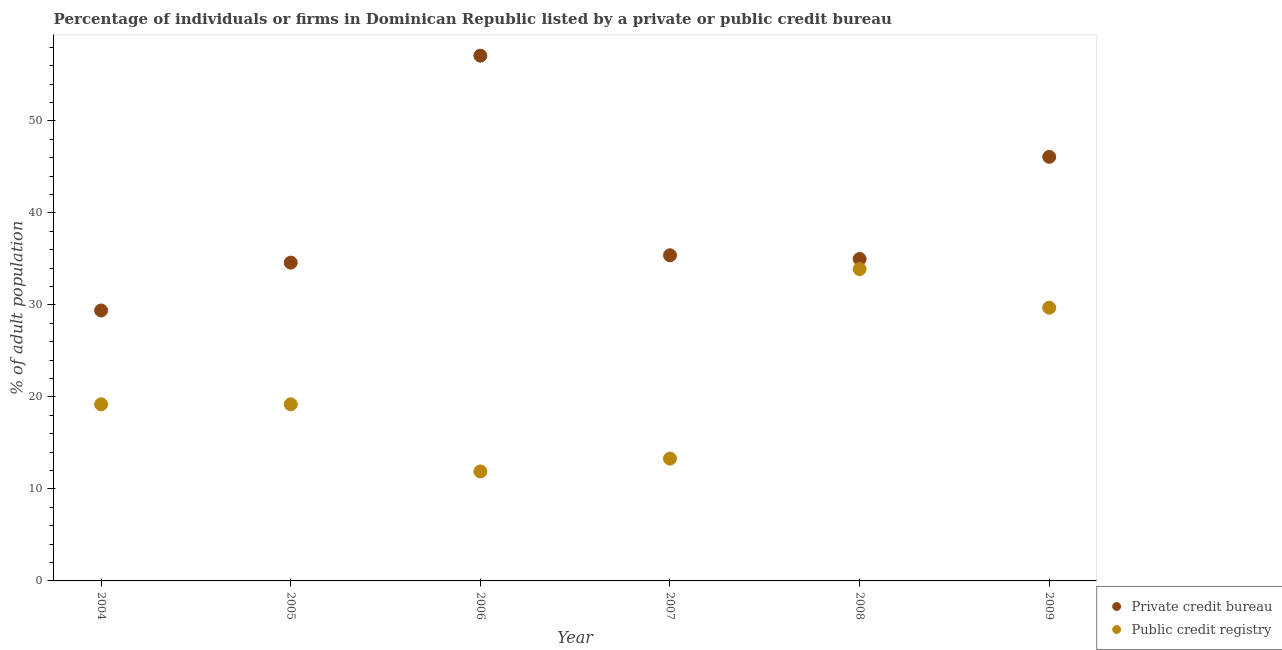Is the number of dotlines equal to the number of legend labels?
Provide a short and direct response. Yes. What is the percentage of firms listed by public credit bureau in 2008?
Make the answer very short. 33.9. Across all years, what is the maximum percentage of firms listed by public credit bureau?
Your answer should be compact. 33.9. Across all years, what is the minimum percentage of firms listed by private credit bureau?
Give a very brief answer. 29.4. In which year was the percentage of firms listed by public credit bureau minimum?
Your answer should be compact. 2006. What is the total percentage of firms listed by private credit bureau in the graph?
Your answer should be compact. 237.6. What is the difference between the percentage of firms listed by public credit bureau in 2007 and that in 2008?
Provide a short and direct response. -20.6. What is the difference between the percentage of firms listed by public credit bureau in 2008 and the percentage of firms listed by private credit bureau in 2009?
Make the answer very short. -12.2. What is the average percentage of firms listed by private credit bureau per year?
Keep it short and to the point. 39.6. In the year 2009, what is the difference between the percentage of firms listed by private credit bureau and percentage of firms listed by public credit bureau?
Your answer should be compact. 16.4. What is the ratio of the percentage of firms listed by public credit bureau in 2004 to that in 2005?
Provide a succinct answer. 1. Is the percentage of firms listed by private credit bureau in 2005 less than that in 2006?
Your response must be concise. Yes. What is the difference between the highest and the second highest percentage of firms listed by public credit bureau?
Your response must be concise. 4.2. Is the percentage of firms listed by public credit bureau strictly greater than the percentage of firms listed by private credit bureau over the years?
Make the answer very short. No. How many years are there in the graph?
Your answer should be compact. 6. Are the values on the major ticks of Y-axis written in scientific E-notation?
Your answer should be compact. No. Does the graph contain grids?
Your answer should be very brief. No. Where does the legend appear in the graph?
Offer a very short reply. Bottom right. How are the legend labels stacked?
Keep it short and to the point. Vertical. What is the title of the graph?
Offer a terse response. Percentage of individuals or firms in Dominican Republic listed by a private or public credit bureau. Does "current US$" appear as one of the legend labels in the graph?
Keep it short and to the point. No. What is the label or title of the X-axis?
Ensure brevity in your answer.  Year. What is the label or title of the Y-axis?
Keep it short and to the point. % of adult population. What is the % of adult population in Private credit bureau in 2004?
Make the answer very short. 29.4. What is the % of adult population of Public credit registry in 2004?
Provide a succinct answer. 19.2. What is the % of adult population of Private credit bureau in 2005?
Provide a succinct answer. 34.6. What is the % of adult population of Public credit registry in 2005?
Keep it short and to the point. 19.2. What is the % of adult population of Private credit bureau in 2006?
Give a very brief answer. 57.1. What is the % of adult population of Public credit registry in 2006?
Give a very brief answer. 11.9. What is the % of adult population in Private credit bureau in 2007?
Offer a very short reply. 35.4. What is the % of adult population of Private credit bureau in 2008?
Your response must be concise. 35. What is the % of adult population of Public credit registry in 2008?
Provide a succinct answer. 33.9. What is the % of adult population in Private credit bureau in 2009?
Your answer should be very brief. 46.1. What is the % of adult population of Public credit registry in 2009?
Provide a succinct answer. 29.7. Across all years, what is the maximum % of adult population in Private credit bureau?
Offer a very short reply. 57.1. Across all years, what is the maximum % of adult population in Public credit registry?
Offer a very short reply. 33.9. Across all years, what is the minimum % of adult population in Private credit bureau?
Provide a succinct answer. 29.4. What is the total % of adult population of Private credit bureau in the graph?
Your answer should be very brief. 237.6. What is the total % of adult population in Public credit registry in the graph?
Ensure brevity in your answer.  127.2. What is the difference between the % of adult population in Private credit bureau in 2004 and that in 2005?
Give a very brief answer. -5.2. What is the difference between the % of adult population of Private credit bureau in 2004 and that in 2006?
Provide a succinct answer. -27.7. What is the difference between the % of adult population in Public credit registry in 2004 and that in 2006?
Ensure brevity in your answer.  7.3. What is the difference between the % of adult population of Private credit bureau in 2004 and that in 2008?
Your response must be concise. -5.6. What is the difference between the % of adult population in Public credit registry in 2004 and that in 2008?
Provide a succinct answer. -14.7. What is the difference between the % of adult population in Private credit bureau in 2004 and that in 2009?
Offer a terse response. -16.7. What is the difference between the % of adult population in Private credit bureau in 2005 and that in 2006?
Your response must be concise. -22.5. What is the difference between the % of adult population in Private credit bureau in 2005 and that in 2007?
Make the answer very short. -0.8. What is the difference between the % of adult population in Public credit registry in 2005 and that in 2007?
Make the answer very short. 5.9. What is the difference between the % of adult population in Public credit registry in 2005 and that in 2008?
Provide a succinct answer. -14.7. What is the difference between the % of adult population of Private credit bureau in 2006 and that in 2007?
Your answer should be compact. 21.7. What is the difference between the % of adult population in Public credit registry in 2006 and that in 2007?
Ensure brevity in your answer.  -1.4. What is the difference between the % of adult population in Private credit bureau in 2006 and that in 2008?
Keep it short and to the point. 22.1. What is the difference between the % of adult population in Public credit registry in 2006 and that in 2009?
Your answer should be compact. -17.8. What is the difference between the % of adult population of Private credit bureau in 2007 and that in 2008?
Your answer should be very brief. 0.4. What is the difference between the % of adult population in Public credit registry in 2007 and that in 2008?
Your answer should be compact. -20.6. What is the difference between the % of adult population of Public credit registry in 2007 and that in 2009?
Give a very brief answer. -16.4. What is the difference between the % of adult population of Private credit bureau in 2008 and that in 2009?
Offer a very short reply. -11.1. What is the difference between the % of adult population in Public credit registry in 2008 and that in 2009?
Ensure brevity in your answer.  4.2. What is the difference between the % of adult population in Private credit bureau in 2004 and the % of adult population in Public credit registry in 2005?
Give a very brief answer. 10.2. What is the difference between the % of adult population in Private credit bureau in 2004 and the % of adult population in Public credit registry in 2007?
Ensure brevity in your answer.  16.1. What is the difference between the % of adult population in Private credit bureau in 2005 and the % of adult population in Public credit registry in 2006?
Make the answer very short. 22.7. What is the difference between the % of adult population of Private credit bureau in 2005 and the % of adult population of Public credit registry in 2007?
Keep it short and to the point. 21.3. What is the difference between the % of adult population in Private credit bureau in 2005 and the % of adult population in Public credit registry in 2008?
Provide a short and direct response. 0.7. What is the difference between the % of adult population of Private credit bureau in 2005 and the % of adult population of Public credit registry in 2009?
Offer a very short reply. 4.9. What is the difference between the % of adult population of Private credit bureau in 2006 and the % of adult population of Public credit registry in 2007?
Offer a terse response. 43.8. What is the difference between the % of adult population of Private credit bureau in 2006 and the % of adult population of Public credit registry in 2008?
Keep it short and to the point. 23.2. What is the difference between the % of adult population in Private credit bureau in 2006 and the % of adult population in Public credit registry in 2009?
Your answer should be compact. 27.4. What is the average % of adult population of Private credit bureau per year?
Your answer should be very brief. 39.6. What is the average % of adult population in Public credit registry per year?
Keep it short and to the point. 21.2. In the year 2005, what is the difference between the % of adult population of Private credit bureau and % of adult population of Public credit registry?
Provide a succinct answer. 15.4. In the year 2006, what is the difference between the % of adult population of Private credit bureau and % of adult population of Public credit registry?
Ensure brevity in your answer.  45.2. In the year 2007, what is the difference between the % of adult population of Private credit bureau and % of adult population of Public credit registry?
Offer a very short reply. 22.1. What is the ratio of the % of adult population in Private credit bureau in 2004 to that in 2005?
Make the answer very short. 0.85. What is the ratio of the % of adult population in Private credit bureau in 2004 to that in 2006?
Your response must be concise. 0.51. What is the ratio of the % of adult population in Public credit registry in 2004 to that in 2006?
Ensure brevity in your answer.  1.61. What is the ratio of the % of adult population of Private credit bureau in 2004 to that in 2007?
Your answer should be very brief. 0.83. What is the ratio of the % of adult population of Public credit registry in 2004 to that in 2007?
Offer a terse response. 1.44. What is the ratio of the % of adult population in Private credit bureau in 2004 to that in 2008?
Offer a very short reply. 0.84. What is the ratio of the % of adult population of Public credit registry in 2004 to that in 2008?
Offer a terse response. 0.57. What is the ratio of the % of adult population of Private credit bureau in 2004 to that in 2009?
Offer a terse response. 0.64. What is the ratio of the % of adult population of Public credit registry in 2004 to that in 2009?
Make the answer very short. 0.65. What is the ratio of the % of adult population in Private credit bureau in 2005 to that in 2006?
Give a very brief answer. 0.61. What is the ratio of the % of adult population of Public credit registry in 2005 to that in 2006?
Provide a succinct answer. 1.61. What is the ratio of the % of adult population in Private credit bureau in 2005 to that in 2007?
Give a very brief answer. 0.98. What is the ratio of the % of adult population in Public credit registry in 2005 to that in 2007?
Offer a very short reply. 1.44. What is the ratio of the % of adult population of Private credit bureau in 2005 to that in 2008?
Keep it short and to the point. 0.99. What is the ratio of the % of adult population of Public credit registry in 2005 to that in 2008?
Provide a succinct answer. 0.57. What is the ratio of the % of adult population in Private credit bureau in 2005 to that in 2009?
Your answer should be very brief. 0.75. What is the ratio of the % of adult population of Public credit registry in 2005 to that in 2009?
Offer a terse response. 0.65. What is the ratio of the % of adult population of Private credit bureau in 2006 to that in 2007?
Ensure brevity in your answer.  1.61. What is the ratio of the % of adult population of Public credit registry in 2006 to that in 2007?
Ensure brevity in your answer.  0.89. What is the ratio of the % of adult population in Private credit bureau in 2006 to that in 2008?
Your response must be concise. 1.63. What is the ratio of the % of adult population of Public credit registry in 2006 to that in 2008?
Your answer should be very brief. 0.35. What is the ratio of the % of adult population in Private credit bureau in 2006 to that in 2009?
Your answer should be very brief. 1.24. What is the ratio of the % of adult population in Public credit registry in 2006 to that in 2009?
Make the answer very short. 0.4. What is the ratio of the % of adult population in Private credit bureau in 2007 to that in 2008?
Your answer should be compact. 1.01. What is the ratio of the % of adult population in Public credit registry in 2007 to that in 2008?
Provide a short and direct response. 0.39. What is the ratio of the % of adult population in Private credit bureau in 2007 to that in 2009?
Ensure brevity in your answer.  0.77. What is the ratio of the % of adult population in Public credit registry in 2007 to that in 2009?
Offer a terse response. 0.45. What is the ratio of the % of adult population in Private credit bureau in 2008 to that in 2009?
Your answer should be very brief. 0.76. What is the ratio of the % of adult population in Public credit registry in 2008 to that in 2009?
Provide a short and direct response. 1.14. What is the difference between the highest and the second highest % of adult population in Private credit bureau?
Your answer should be very brief. 11. What is the difference between the highest and the second highest % of adult population of Public credit registry?
Make the answer very short. 4.2. What is the difference between the highest and the lowest % of adult population in Private credit bureau?
Offer a terse response. 27.7. 